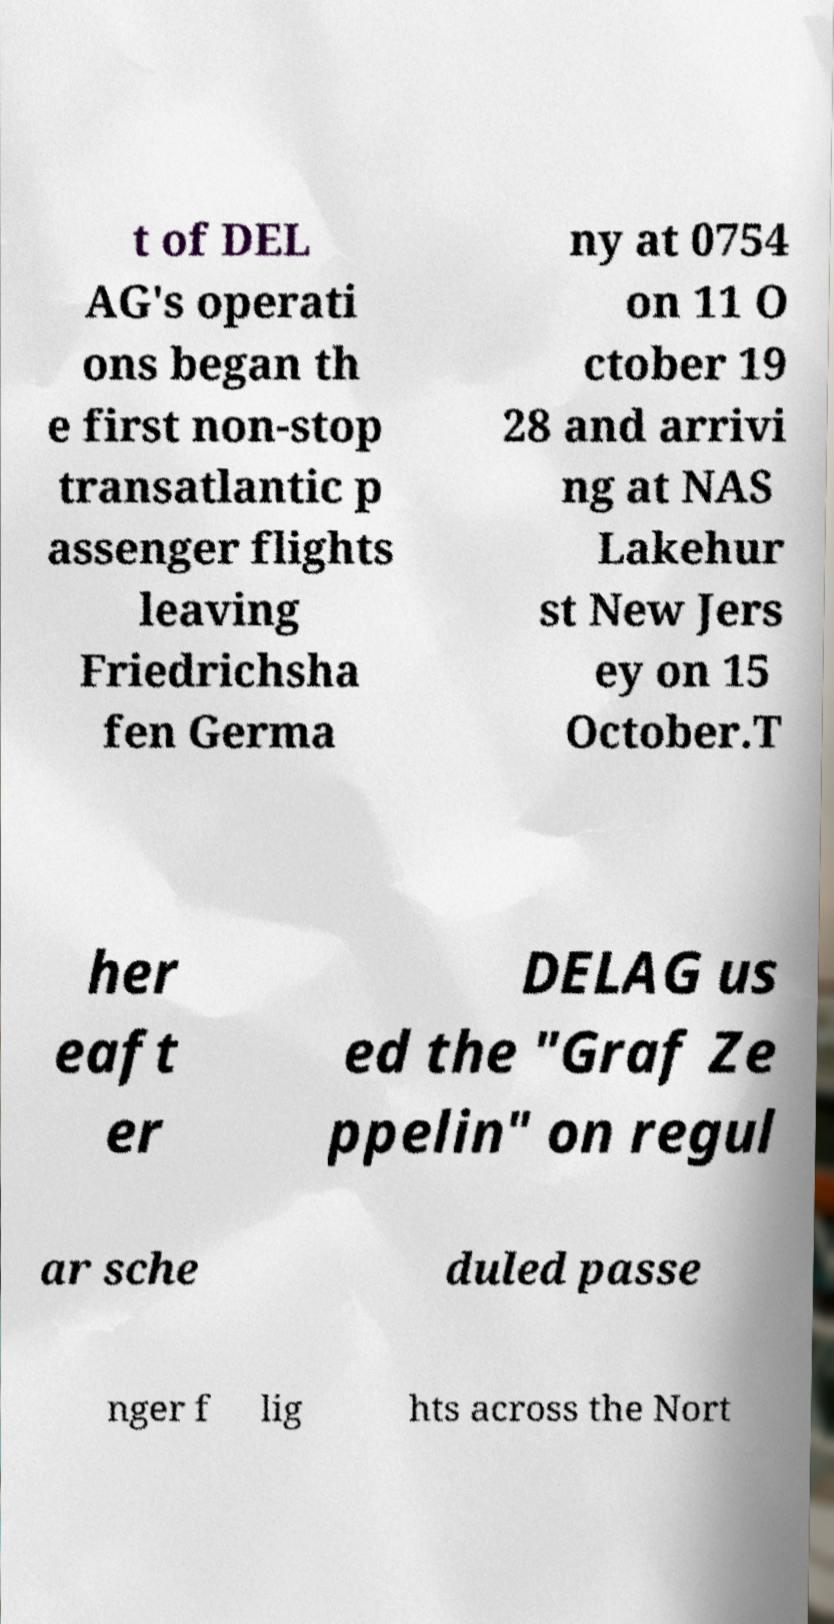Please read and relay the text visible in this image. What does it say? t of DEL AG's operati ons began th e first non-stop transatlantic p assenger flights leaving Friedrichsha fen Germa ny at 0754 on 11 O ctober 19 28 and arrivi ng at NAS Lakehur st New Jers ey on 15 October.T her eaft er DELAG us ed the "Graf Ze ppelin" on regul ar sche duled passe nger f lig hts across the Nort 